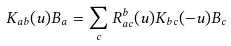<formula> <loc_0><loc_0><loc_500><loc_500>K _ { a b } ( u ) { B } _ { a } = \sum _ { c } R ^ { b } _ { a c } ( u ) K _ { b c } ( - u ) { B } _ { c }</formula> 